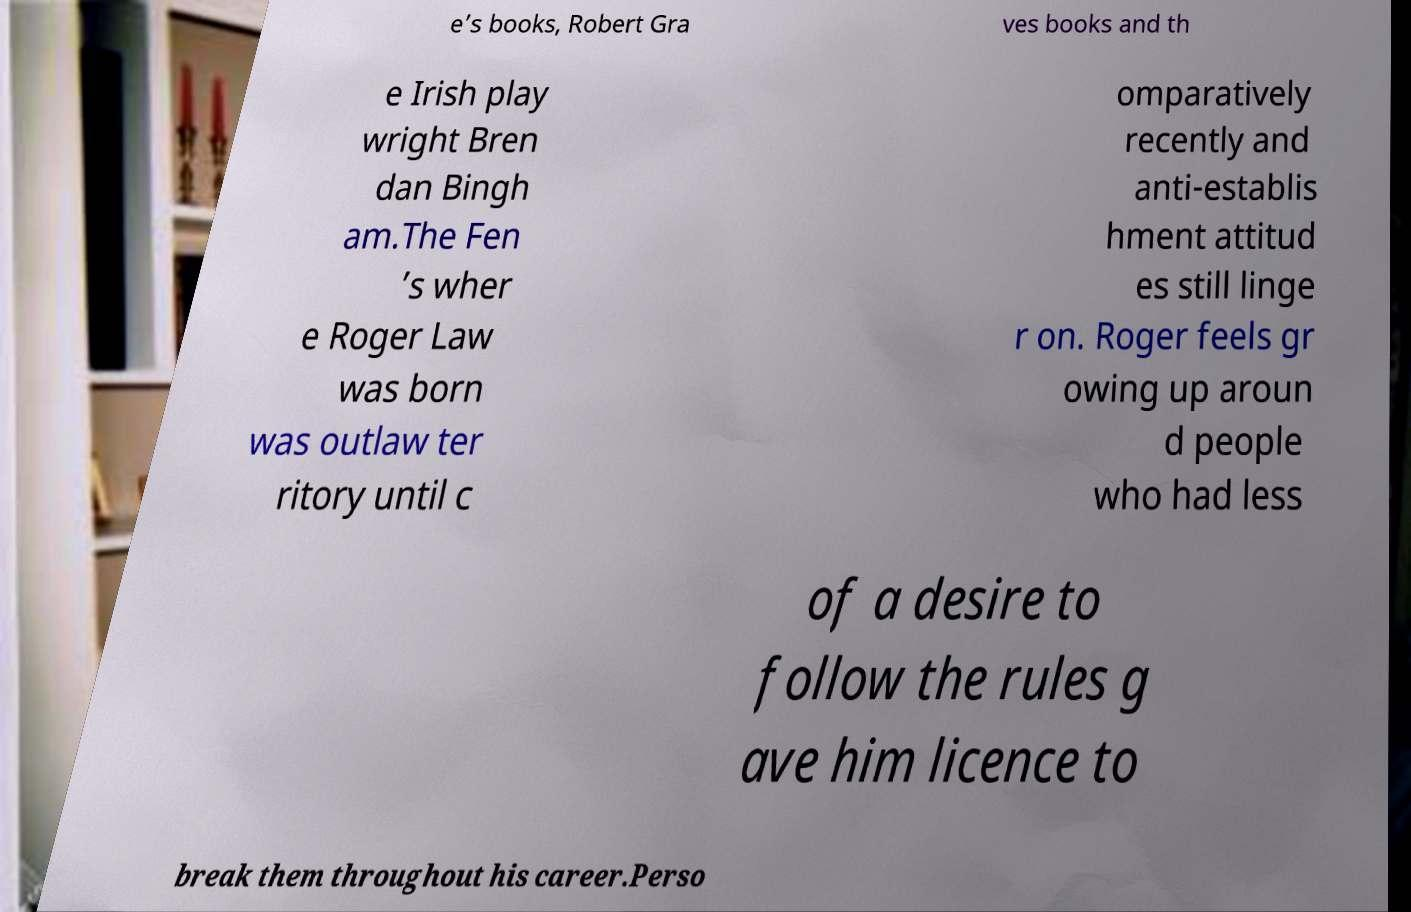Can you read and provide the text displayed in the image?This photo seems to have some interesting text. Can you extract and type it out for me? e’s books, Robert Gra ves books and th e Irish play wright Bren dan Bingh am.The Fen ’s wher e Roger Law was born was outlaw ter ritory until c omparatively recently and anti-establis hment attitud es still linge r on. Roger feels gr owing up aroun d people who had less of a desire to follow the rules g ave him licence to break them throughout his career.Perso 